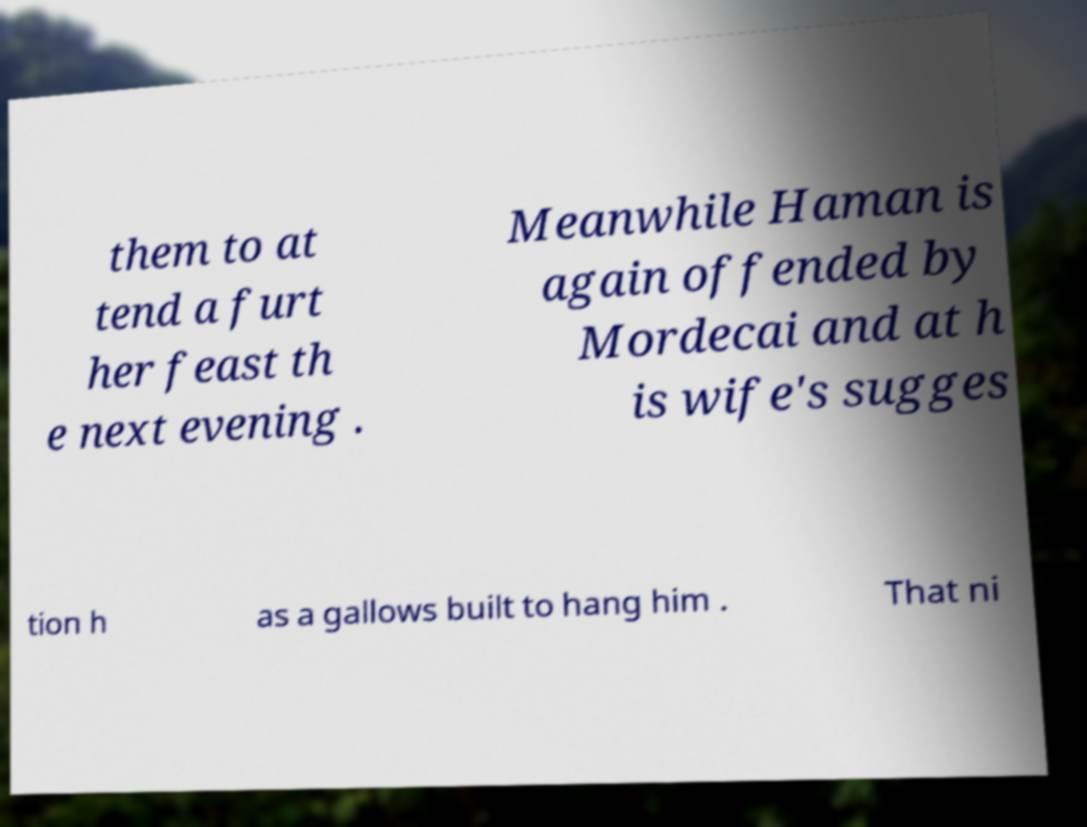I need the written content from this picture converted into text. Can you do that? them to at tend a furt her feast th e next evening . Meanwhile Haman is again offended by Mordecai and at h is wife's sugges tion h as a gallows built to hang him . That ni 